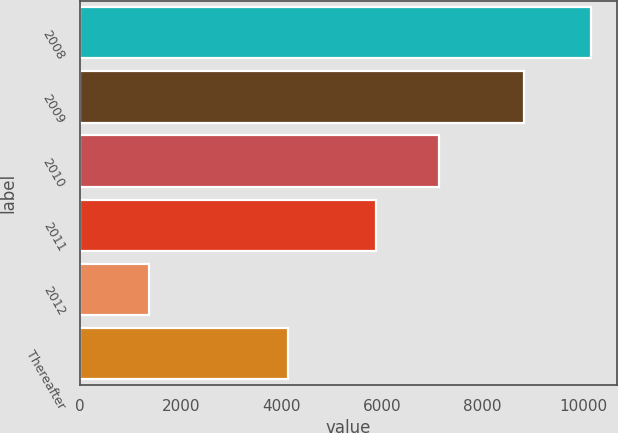<chart> <loc_0><loc_0><loc_500><loc_500><bar_chart><fcel>2008<fcel>2009<fcel>2010<fcel>2011<fcel>2012<fcel>Thereafter<nl><fcel>10158<fcel>8829<fcel>7127<fcel>5870<fcel>1361<fcel>4136<nl></chart> 